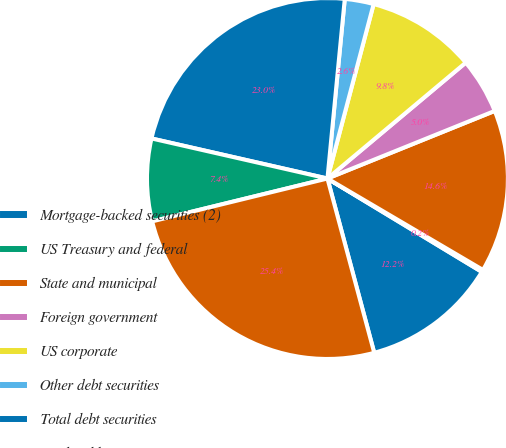Convert chart. <chart><loc_0><loc_0><loc_500><loc_500><pie_chart><fcel>Mortgage-backed securities (2)<fcel>US Treasury and federal<fcel>State and municipal<fcel>Foreign government<fcel>US corporate<fcel>Other debt securities<fcel>Total debt securities<fcel>Marketable equity securities<fcel>Total securities<nl><fcel>12.17%<fcel>0.2%<fcel>14.57%<fcel>4.99%<fcel>9.78%<fcel>2.59%<fcel>22.97%<fcel>7.38%<fcel>25.36%<nl></chart> 